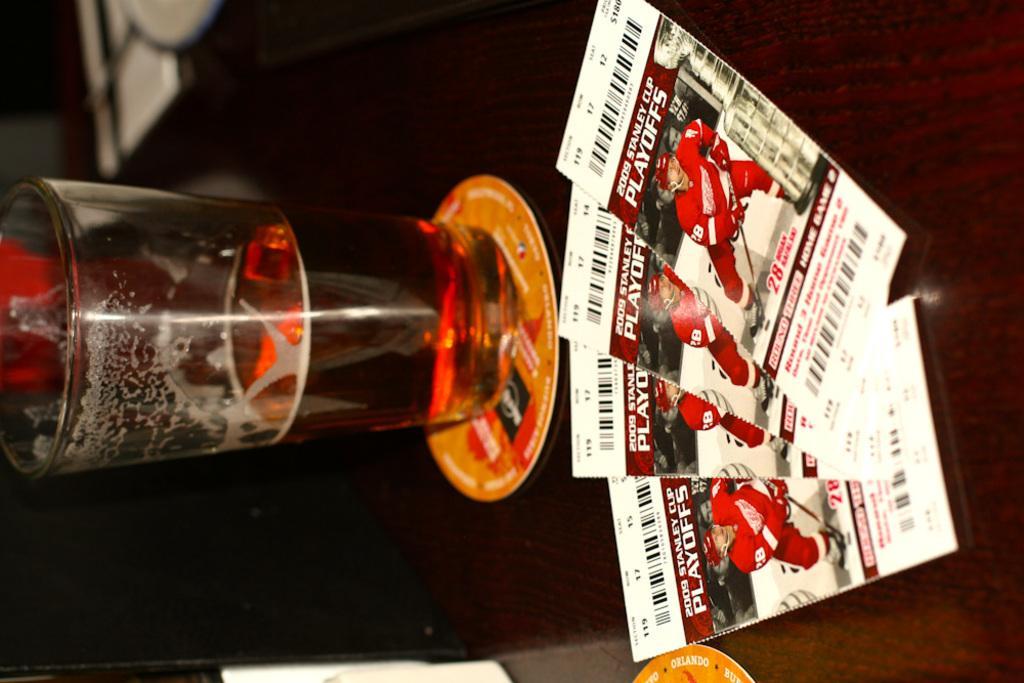Please provide a concise description of this image. In the center of the image there is a table and we can see a glass and papers placed on the table. 